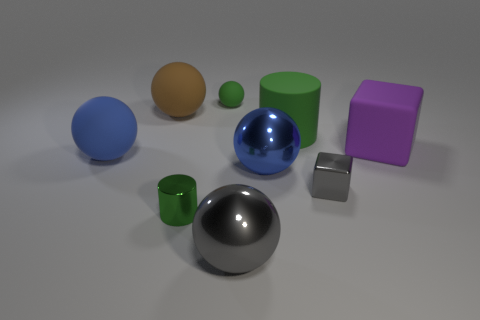What number of yellow metallic objects have the same size as the green ball?
Offer a terse response. 0. There is a shiny object on the left side of the green ball; what is its shape?
Ensure brevity in your answer.  Cylinder. Are there fewer small gray objects than large objects?
Make the answer very short. Yes. Is there any other thing of the same color as the large matte cube?
Your response must be concise. No. There is a blue object in front of the blue matte ball; what size is it?
Give a very brief answer. Large. Is the number of objects greater than the number of big gray rubber things?
Make the answer very short. Yes. What is the material of the small gray object?
Provide a succinct answer. Metal. How many other objects are there of the same material as the large brown object?
Keep it short and to the point. 4. What number of big cyan shiny blocks are there?
Make the answer very short. 0. There is a big gray thing that is the same shape as the brown matte object; what is it made of?
Offer a very short reply. Metal. 